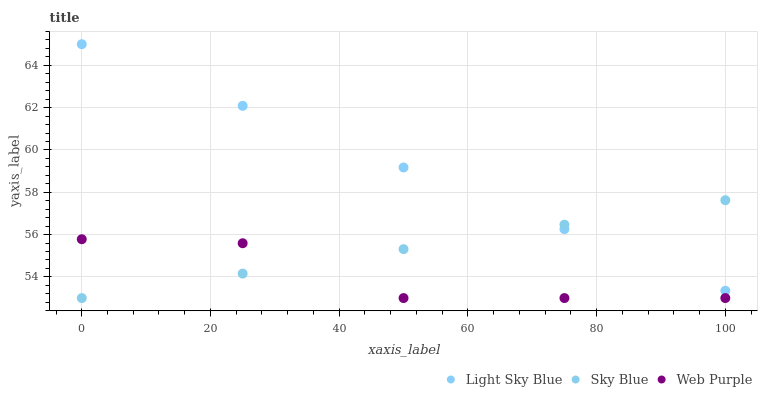Does Web Purple have the minimum area under the curve?
Answer yes or no. Yes. Does Light Sky Blue have the maximum area under the curve?
Answer yes or no. Yes. Does Light Sky Blue have the minimum area under the curve?
Answer yes or no. No. Does Web Purple have the maximum area under the curve?
Answer yes or no. No. Is Light Sky Blue the smoothest?
Answer yes or no. Yes. Is Web Purple the roughest?
Answer yes or no. Yes. Is Web Purple the smoothest?
Answer yes or no. No. Is Light Sky Blue the roughest?
Answer yes or no. No. Does Sky Blue have the lowest value?
Answer yes or no. Yes. Does Light Sky Blue have the lowest value?
Answer yes or no. No. Does Light Sky Blue have the highest value?
Answer yes or no. Yes. Does Web Purple have the highest value?
Answer yes or no. No. Is Web Purple less than Light Sky Blue?
Answer yes or no. Yes. Is Light Sky Blue greater than Web Purple?
Answer yes or no. Yes. Does Sky Blue intersect Web Purple?
Answer yes or no. Yes. Is Sky Blue less than Web Purple?
Answer yes or no. No. Is Sky Blue greater than Web Purple?
Answer yes or no. No. Does Web Purple intersect Light Sky Blue?
Answer yes or no. No. 